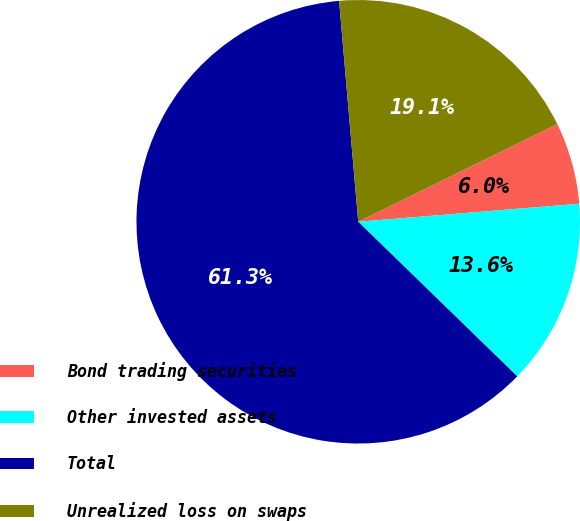Convert chart. <chart><loc_0><loc_0><loc_500><loc_500><pie_chart><fcel>Bond trading securities<fcel>Other invested assets<fcel>Total<fcel>Unrealized loss on swaps<nl><fcel>5.97%<fcel>13.57%<fcel>61.35%<fcel>19.11%<nl></chart> 